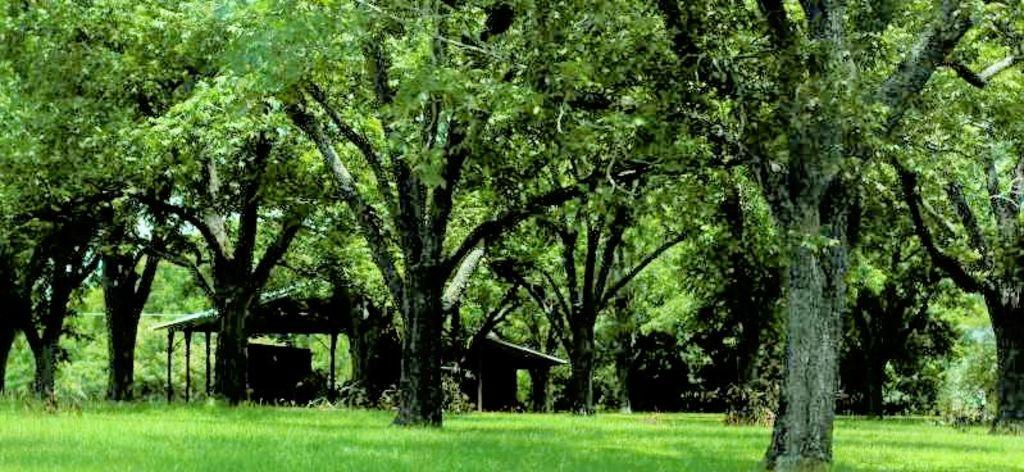What type of vegetation is at the bottom of the picture? There is grass at the bottom of the picture. What can be seen in the background of the image? There are trees and a shed in the background of the image. What type of wound can be seen on the tree in the image? There is no wound visible on the tree in the image. What type of card is hanging from the shed in the image? There is no card hanging from the shed in the image. 